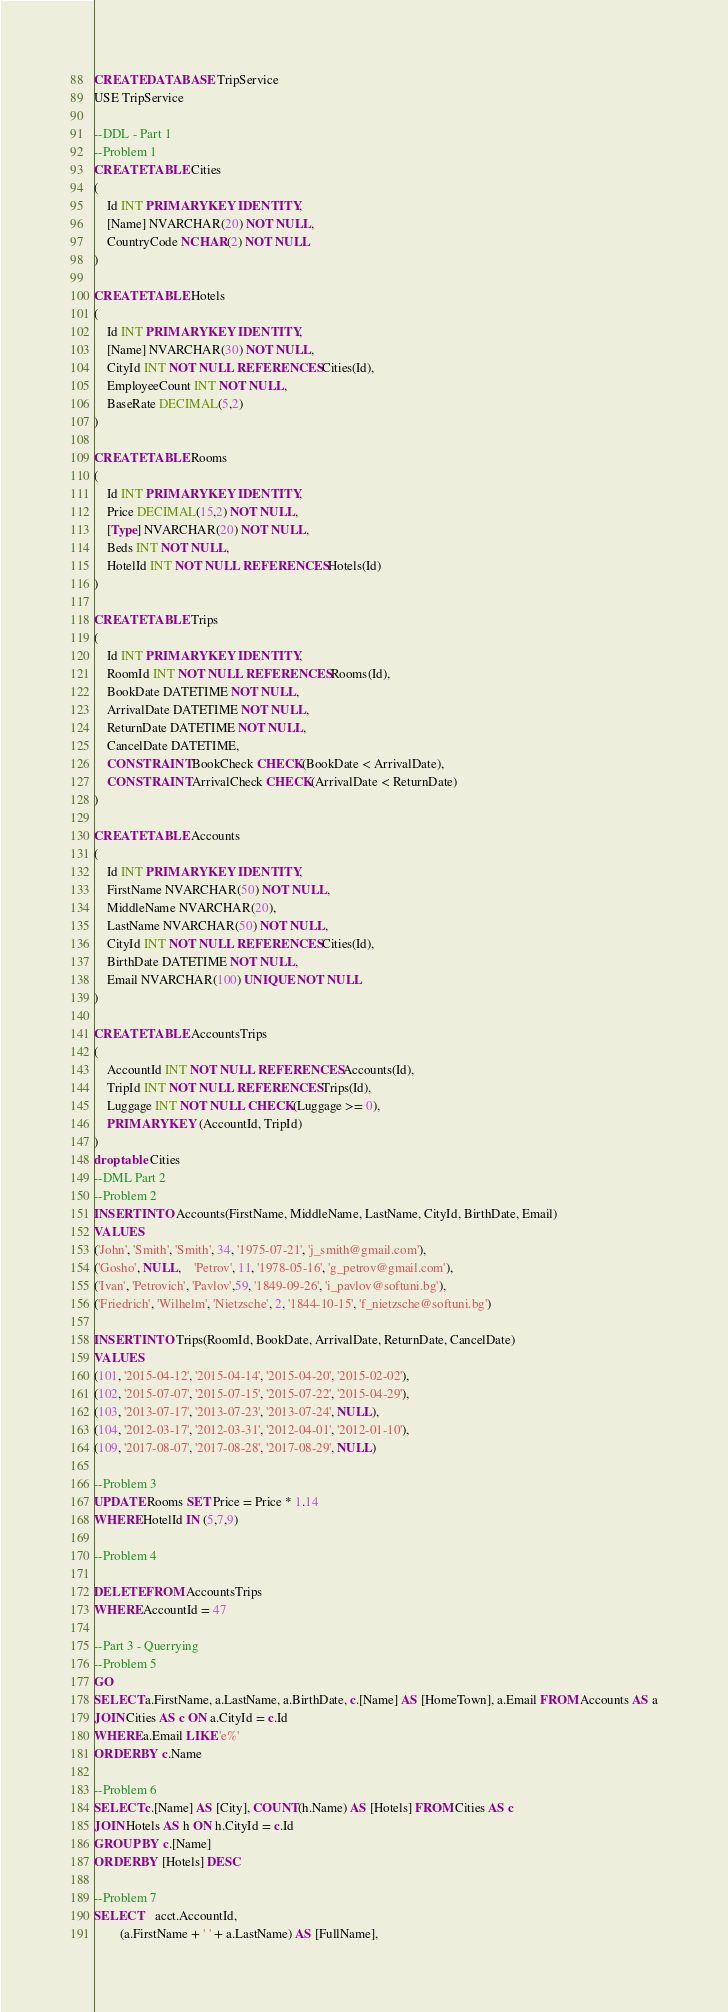<code> <loc_0><loc_0><loc_500><loc_500><_SQL_>CREATE DATABASE TripService
USE TripService

--DDL - Part 1
--Problem 1
CREATE TABLE Cities
(
	Id INT PRIMARY KEY IDENTITY,
	[Name] NVARCHAR(20) NOT NULL,
	CountryCode NCHAR(2) NOT NULL
)

CREATE TABLE Hotels
(
	Id INT PRIMARY KEY IDENTITY,
	[Name] NVARCHAR(30) NOT NULL,
	CityId INT NOT NULL REFERENCES Cities(Id),
	EmployeeCount INT NOT NULL,
	BaseRate DECIMAL(5,2)
)

CREATE TABLE Rooms
(
	Id INT PRIMARY KEY IDENTITY,
	Price DECIMAL(15,2) NOT NULL,
	[Type] NVARCHAR(20) NOT NULL,
	Beds INT NOT NULL,
	HotelId INT NOT NULL REFERENCES Hotels(Id)
)

CREATE TABLE Trips
(
	Id INT PRIMARY KEY IDENTITY,
	RoomId INT NOT NULL REFERENCES Rooms(Id),
	BookDate DATETIME NOT NULL,
	ArrivalDate DATETIME NOT NULL,
	ReturnDate DATETIME NOT NULL,
	CancelDate DATETIME,
	CONSTRAINT BookCheck CHECK(BookDate < ArrivalDate), 
	CONSTRAINT ArrivalCheck CHECK(ArrivalDate < ReturnDate)
)

CREATE TABLE Accounts
(
	Id INT PRIMARY KEY IDENTITY,
	FirstName NVARCHAR(50) NOT NULL,
	MiddleName NVARCHAR(20),
	LastName NVARCHAR(50) NOT NULL,
	CityId INT NOT NULL REFERENCES Cities(Id),
	BirthDate DATETIME NOT NULL,
	Email NVARCHAR(100) UNIQUE NOT NULL
)

CREATE TABLE AccountsTrips
(
	AccountId INT NOT NULL REFERENCES Accounts(Id),
	TripId INT NOT NULL REFERENCES Trips(Id),
	Luggage INT NOT NULL CHECK(Luggage >= 0),
	PRIMARY KEY (AccountId, TripId)
)
drop table Cities
--DML Part 2
--Problem 2
INSERT INTO Accounts(FirstName, MiddleName, LastName, CityId, BirthDate, Email)
VALUES
('John', 'Smith', 'Smith', 34, '1975-07-21', 'j_smith@gmail.com'),
('Gosho', NULL,	'Petrov', 11, '1978-05-16', 'g_petrov@gmail.com'),
('Ivan', 'Petrovich', 'Pavlov',59, '1849-09-26', 'i_pavlov@softuni.bg'),
('Friedrich', 'Wilhelm', 'Nietzsche', 2, '1844-10-15', 'f_nietzsche@softuni.bg')

INSERT INTO Trips(RoomId, BookDate, ArrivalDate, ReturnDate, CancelDate)
VALUES
(101, '2015-04-12', '2015-04-14', '2015-04-20', '2015-02-02'),
(102, '2015-07-07', '2015-07-15', '2015-07-22', '2015-04-29'),
(103, '2013-07-17', '2013-07-23', '2013-07-24', NULL),
(104, '2012-03-17', '2012-03-31', '2012-04-01', '2012-01-10'),
(109, '2017-08-07', '2017-08-28', '2017-08-29', NULL)

--Problem 3
UPDATE Rooms SET Price = Price * 1.14
WHERE HotelId IN (5,7,9)

--Problem 4

DELETE FROM AccountsTrips
WHERE AccountId = 47

--Part 3 - Querrying
--Problem 5
GO
SELECT a.FirstName, a.LastName, a.BirthDate, c.[Name] AS [HomeTown], a.Email FROM Accounts AS a
JOIN Cities AS c ON a.CityId = c.Id
WHERE a.Email LIKE 'e%'
ORDER BY c.Name

--Problem 6
SELECT c.[Name] AS [City], COUNT(h.Name) AS [Hotels] FROM Cities AS c
JOIN Hotels AS h ON h.CityId = c.Id
GROUP BY c.[Name]
ORDER BY [Hotels] DESC

--Problem 7
SELECT	acct.AccountId,
		(a.FirstName + ' ' + a.LastName) AS [FullName],</code> 